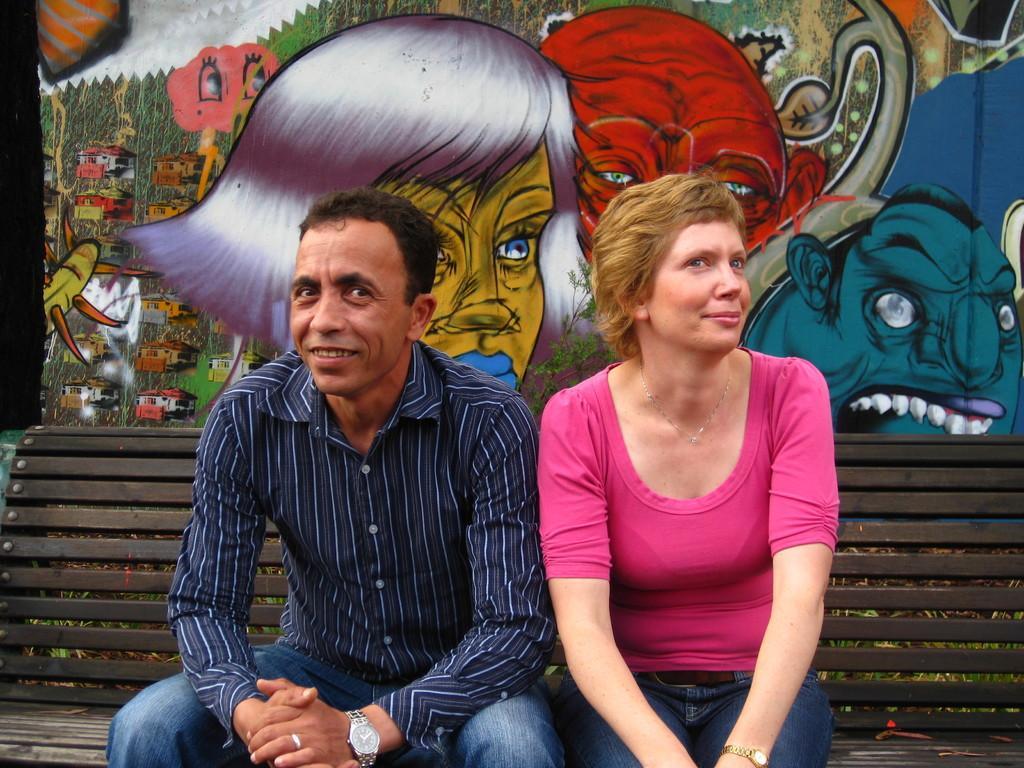Could you give a brief overview of what you see in this image? In this image there are two persons truncated towards the bottom of the image, the persons are sitting on the bench, the bench is truncated, at the background of the image there is a wall truncated, there is a painting on the wall. 